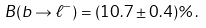Convert formula to latex. <formula><loc_0><loc_0><loc_500><loc_500>B ( b \rightarrow \ell ^ { - } ) = ( 1 0 . 7 \pm 0 . 4 ) \% \, .</formula> 